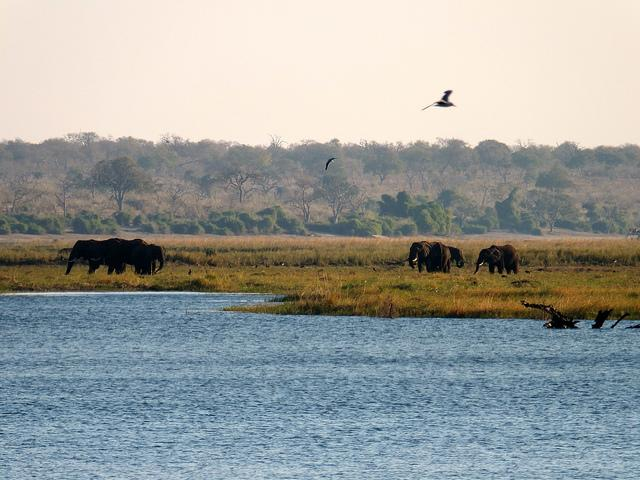Besides Africa what continent can these animals be found naturally on? asia 